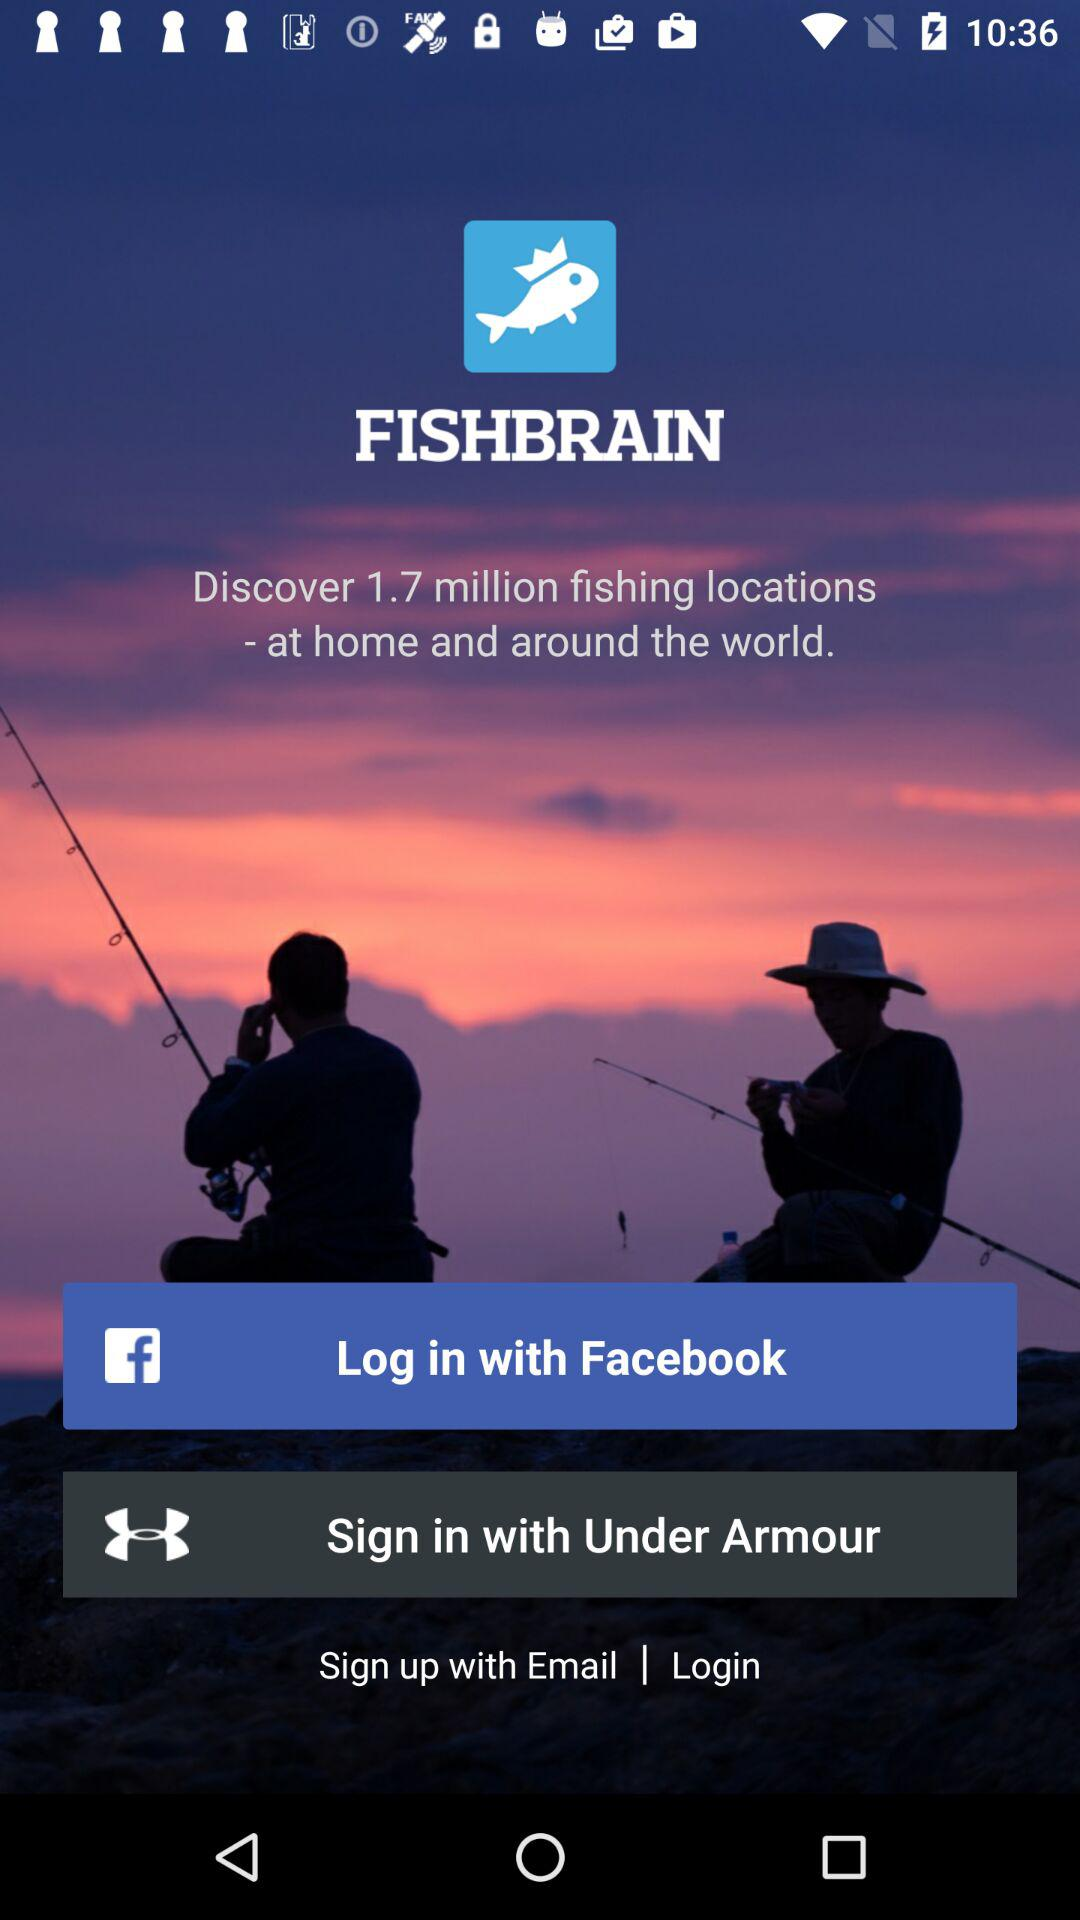How many login options are available?
Answer the question using a single word or phrase. 3 